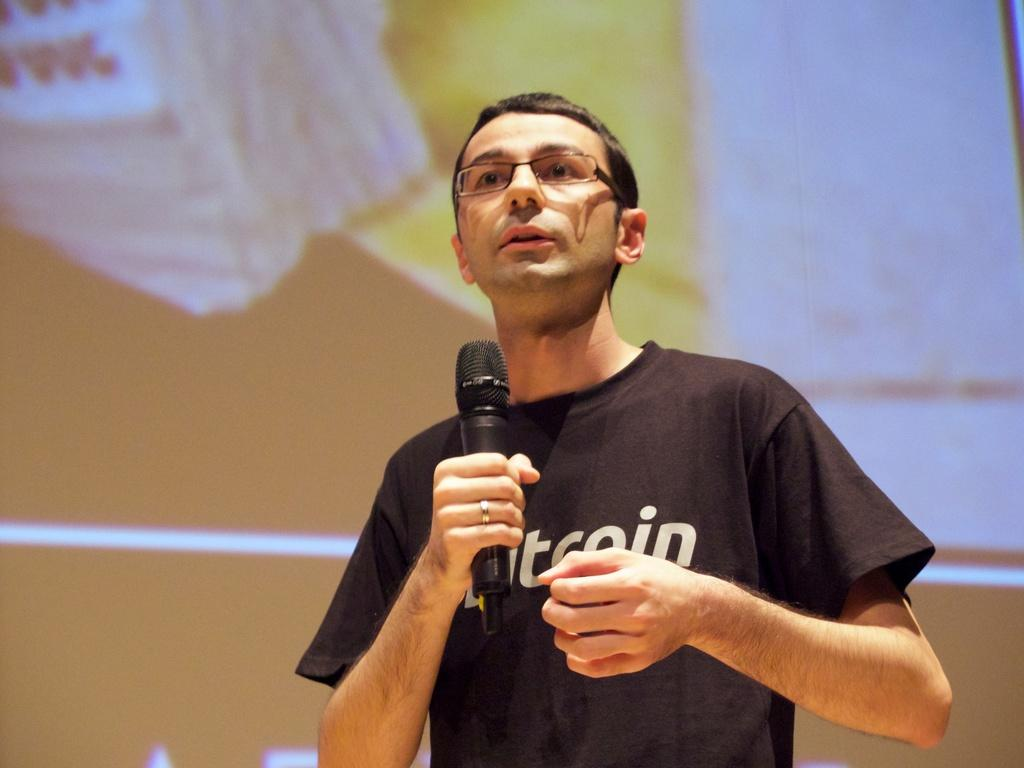What is the man in the image holding? The man is holding a microphone. What can be seen on the man's face in the image? The man is wearing spectacles. What is the man wearing on his upper body in the image? The man is wearing a black t-shirt. What type of cherry is the man eating in the image? There is no cherry present in the image, and the man is not eating anything. What is the condition of the rod in the image? There is no rod present in the image. 